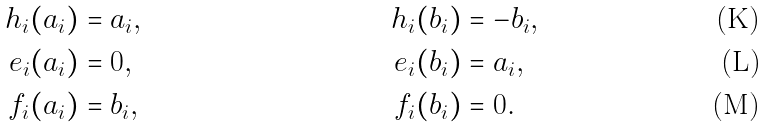Convert formula to latex. <formula><loc_0><loc_0><loc_500><loc_500>h _ { i } ( a _ { i } ) & = a _ { i } , & \quad h _ { i } ( b _ { i } ) & = - b _ { i } , \\ e _ { i } ( a _ { i } ) & = 0 , & e _ { i } ( b _ { i } ) & = a _ { i } , \\ f _ { i } ( a _ { i } ) & = b _ { i } , & f _ { i } ( b _ { i } ) & = 0 .</formula> 